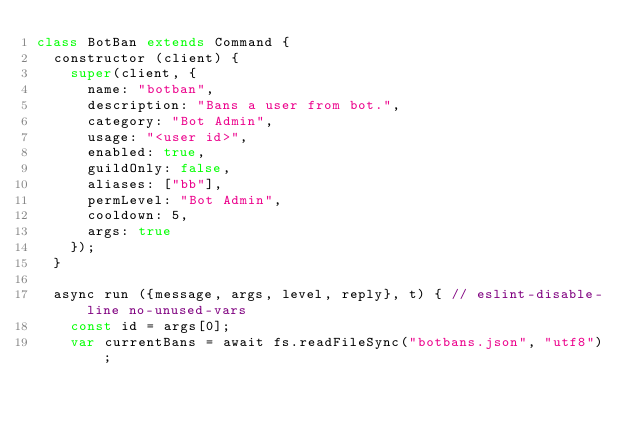<code> <loc_0><loc_0><loc_500><loc_500><_JavaScript_>class BotBan extends Command {
  constructor (client) {
    super(client, {
      name: "botban",
      description: "Bans a user from bot.",
      category: "Bot Admin",
      usage: "<user id>",
      enabled: true,
      guildOnly: false,
      aliases: ["bb"],
      permLevel: "Bot Admin",
      cooldown: 5,
      args: true
    });
  }

  async run ({message, args, level, reply}, t) { // eslint-disable-line no-unused-vars
    const id = args[0];
    var currentBans = await fs.readFileSync("botbans.json", "utf8");</code> 